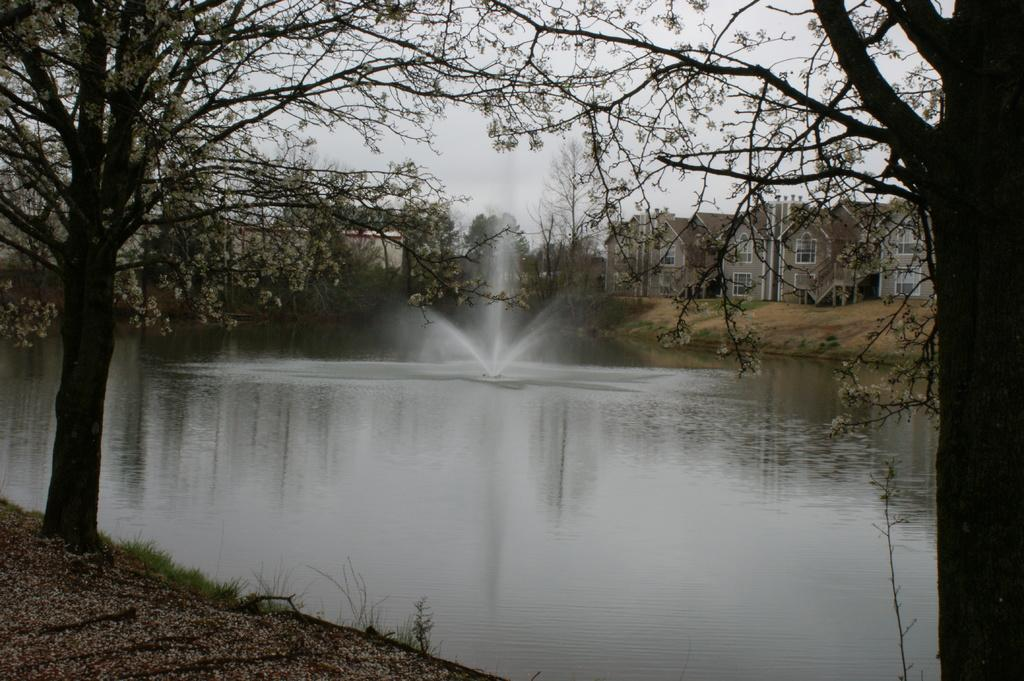What is visible in the image? Water, trees, buildings, and the sky are visible in the image. Can you describe the natural elements in the image? There are trees visible in the image. What can be seen in the background of the image? There are buildings and the sky visible in the background of the image. Can you see a match being lit in the image? There is no match being lit in the image. Is there a kitten visible in the image? There is no kitten present in the image. 